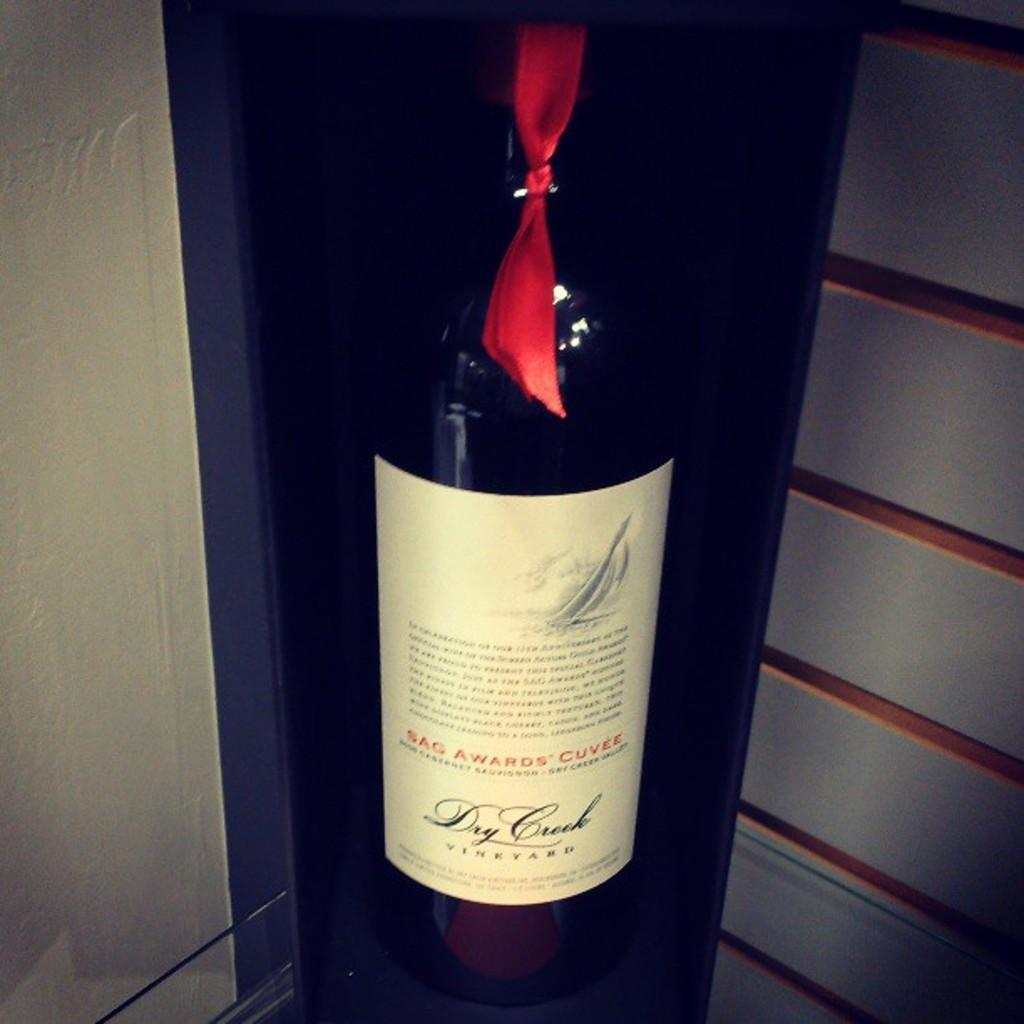<image>
Offer a succinct explanation of the picture presented. A bottle says Sag Awards Cuvee on the label in red letters. 